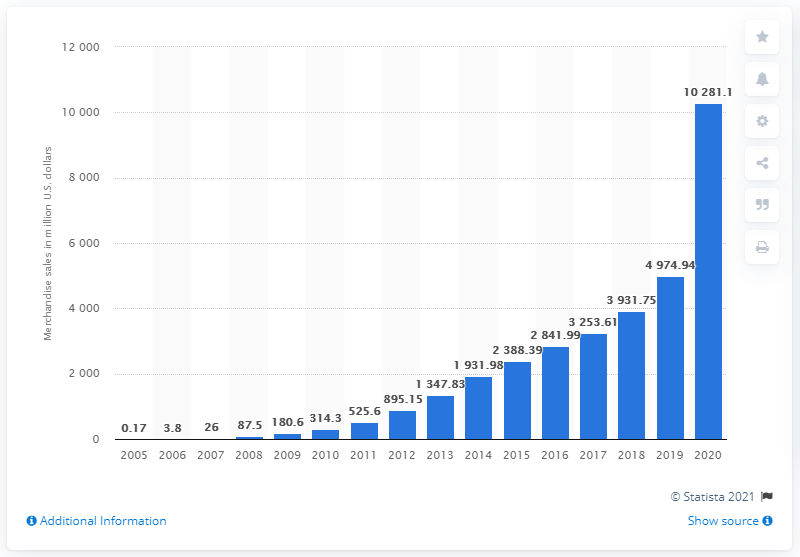Mention a couple of crucial points in this snapshot. In 2010, Etsy's Gross Merchandise Volume (GMV) was 314.3 million dollars. In 2020, Etsy's annual merchandise sales volume was approximately 10,281.1 million dollars. 